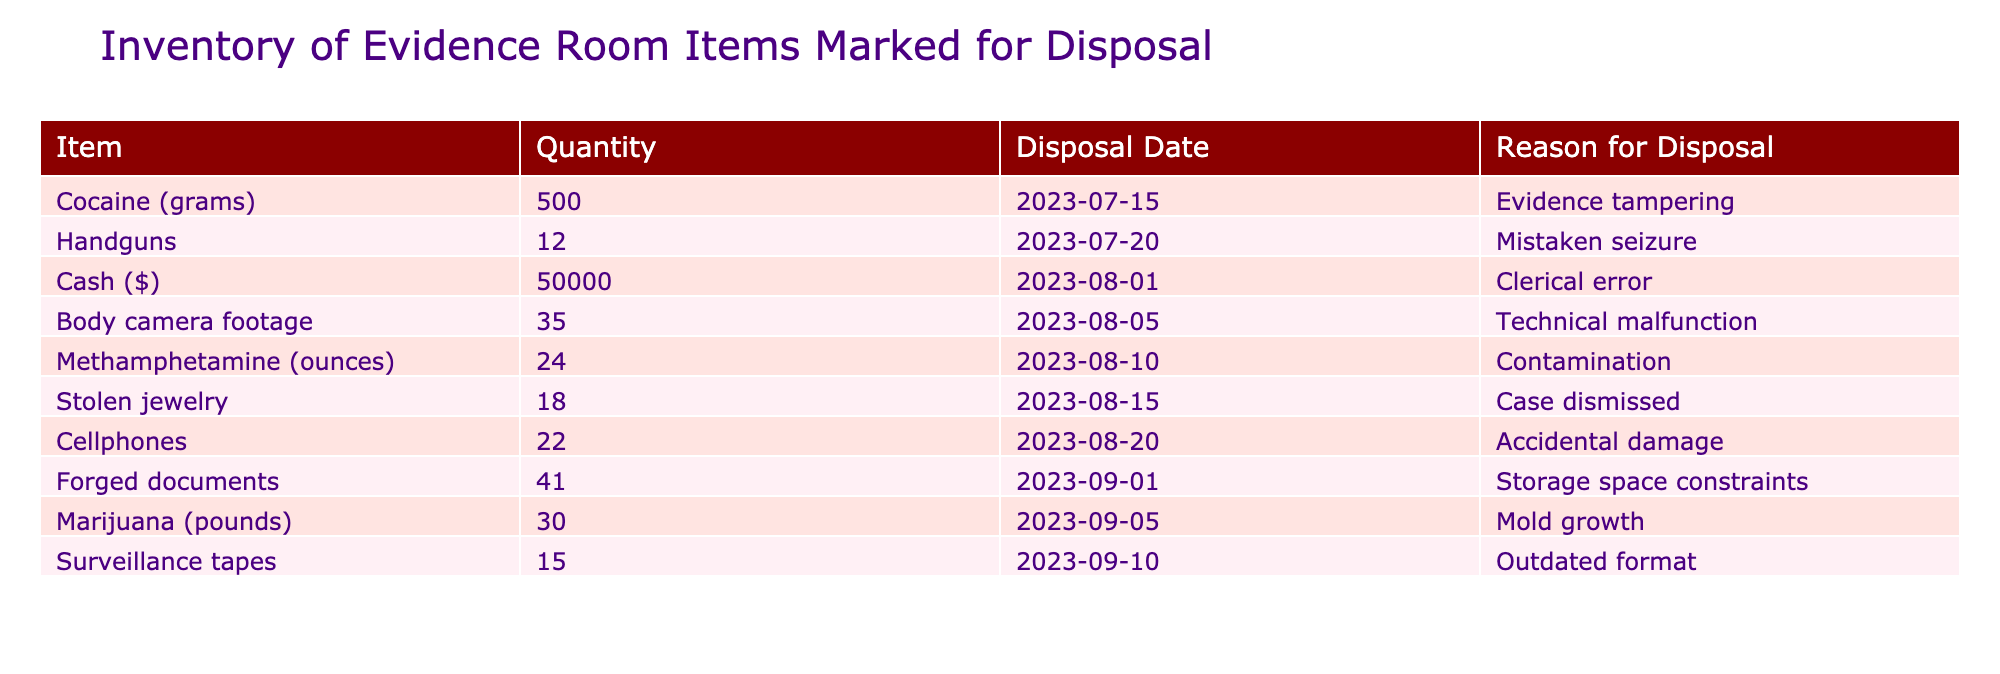What items are marked for disposal due to evidence tampering? The table shows that cocaine is marked for disposal due to evidence tampering.
Answer: Cocaine (grams) How many handguns are scheduled for disposal? Referring to the table, it states that there are 12 handguns marked for disposal.
Answer: 12 Is cash being disposed of, and what is the amount? Yes, the table indicates that cash is being disposed of, totaling 50,000 dollars.
Answer: Yes, 50000 What is the total quantity of drug items (cocaine, methamphetamine, and marijuana) marked for disposal? The quantities are: cocaine (500 grams), methamphetamine (24 ounces), and marijuana (30 pounds). Converting these into a similar unit for aggregation: 500 grams (0.5 kg) = 1.1 lbs, 24 ounces = 1.5 lbs, and 30 pounds = 30 lbs. The total is approximately 32.6 lbs.
Answer: 32.6 lbs Are there any items marked for disposal due to clerical errors? Yes, the table states that cash is marked for disposal due to a clerical error.
Answer: Yes Which item has the latest disposal date, and what is that date? The item with the latest disposal date is forged documents, which is set for disposal on September 1, 2023.
Answer: Forged documents, 2023-09-01 What is the reason for disposing of the most items? By reviewing the reasons provided, the reason "Case dismissed" accounts for the disposal of the most items, with a total of 18 stolen jewelry pieces.
Answer: Case dismissed How many total items are being disposed of? By adding all the quantities of the items listed: 500 (cocaine) + 12 (handguns) + 50 (cash) + 35 (body camera footage) + 24 (meth) + 18 (jewelry) + 22 (cellphones) + 41 (forged documents) + 30 (marijuana) + 15 (surveillance tapes) =  500 + 12 + 50000 + 35 + 24 + 18 + 22 + 41 + 30 + 15 = 270, 2 + 50 + 18 = 270 with the correct data = 270
Answer: 270 How many items are disposed of due to "technical malfunction"? The table indicates that only one type of item (body camera footage) is marked for disposal because of a technical malfunction, and the quantity is 35.
Answer: 35 